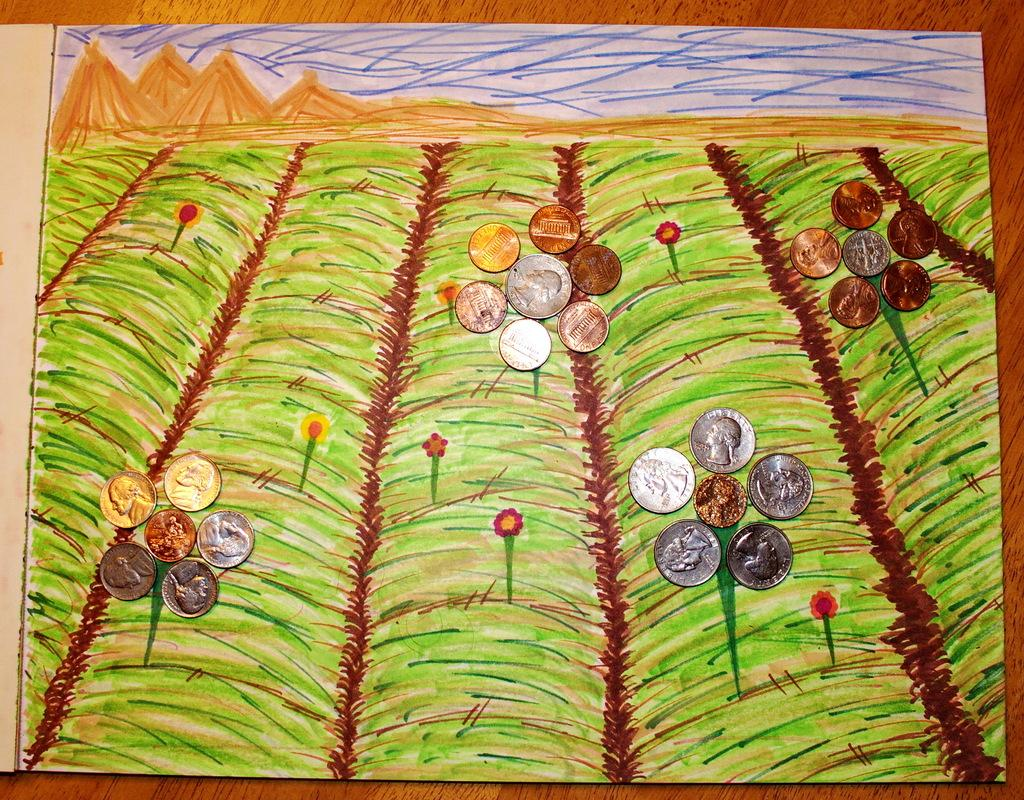What is present on the table in the image? There is a paper on the table. What is depicted on the paper? There is a drawing on the paper. Are there any additional items on the paper? Yes, there are coins on the paper. How many ducks are swimming in the water near the table in the image? There are no ducks present in the image; it only features a table with a paper, drawing, and coins. 